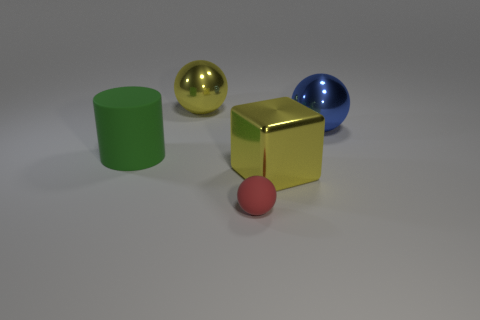Add 4 blocks. How many objects exist? 9 Subtract all cylinders. How many objects are left? 4 Subtract 0 green blocks. How many objects are left? 5 Subtract all large yellow metal things. Subtract all rubber cylinders. How many objects are left? 2 Add 2 green cylinders. How many green cylinders are left? 3 Add 3 blue metal cubes. How many blue metal cubes exist? 3 